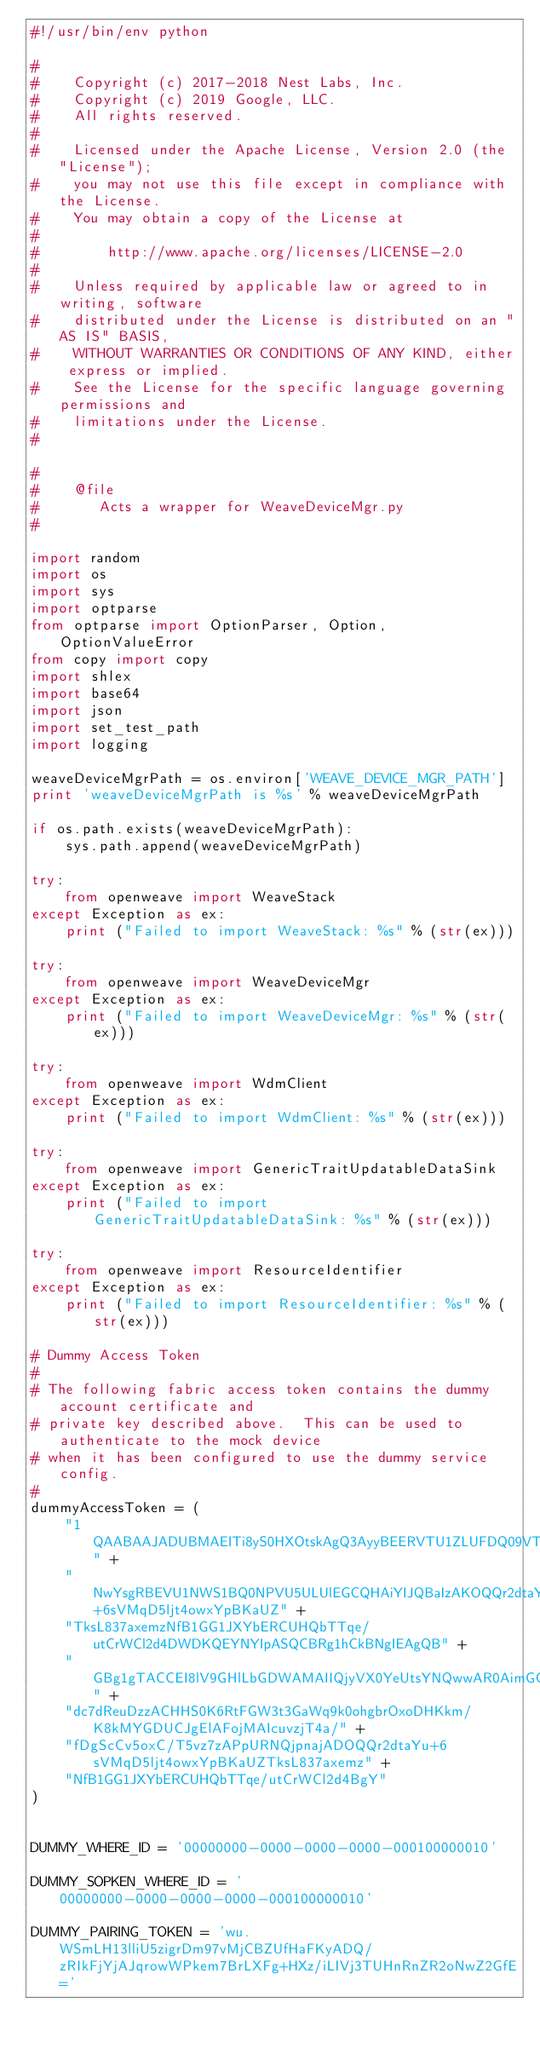Convert code to text. <code><loc_0><loc_0><loc_500><loc_500><_Python_>#!/usr/bin/env python

#
#    Copyright (c) 2017-2018 Nest Labs, Inc.
#    Copyright (c) 2019 Google, LLC.
#    All rights reserved.
#
#    Licensed under the Apache License, Version 2.0 (the "License");
#    you may not use this file except in compliance with the License.
#    You may obtain a copy of the License at
#
#        http://www.apache.org/licenses/LICENSE-2.0
#
#    Unless required by applicable law or agreed to in writing, software
#    distributed under the License is distributed on an "AS IS" BASIS,
#    WITHOUT WARRANTIES OR CONDITIONS OF ANY KIND, either express or implied.
#    See the License for the specific language governing permissions and
#    limitations under the License.
#

#
#    @file
#       Acts a wrapper for WeaveDeviceMgr.py
#

import random
import os
import sys
import optparse
from optparse import OptionParser, Option, OptionValueError
from copy import copy
import shlex
import base64
import json
import set_test_path
import logging

weaveDeviceMgrPath = os.environ['WEAVE_DEVICE_MGR_PATH']
print 'weaveDeviceMgrPath is %s' % weaveDeviceMgrPath

if os.path.exists(weaveDeviceMgrPath):
    sys.path.append(weaveDeviceMgrPath)

try:
    from openweave import WeaveStack
except Exception as ex:
    print ("Failed to import WeaveStack: %s" % (str(ex)))

try:
    from openweave import WeaveDeviceMgr
except Exception as ex:
    print ("Failed to import WeaveDeviceMgr: %s" % (str(ex)))

try:
    from openweave import WdmClient
except Exception as ex:
    print ("Failed to import WdmClient: %s" % (str(ex)))

try:
    from openweave import GenericTraitUpdatableDataSink
except Exception as ex:
    print ("Failed to import GenericTraitUpdatableDataSink: %s" % (str(ex)))

try:
    from openweave import ResourceIdentifier
except Exception as ex:
    print ("Failed to import ResourceIdentifier: %s" % (str(ex)))

# Dummy Access Token
#
# The following fabric access token contains the dummy account certificate and
# private key described above.  This can be used to authenticate to the mock device
# when it has been configured to use the dummy service config.
#
dummyAccessToken = (
    "1QAABAAJADUBMAEITi8yS0HXOtskAgQ3AyyBEERVTU1ZLUFDQ09VTlQtSUQYJgTLqPobJgVLNU9C" +
    "NwYsgRBEVU1NWS1BQ0NPVU5ULUlEGCQHAiYIJQBaIzAKOQQr2dtaYu+6sVMqD5ljt4owxYpBKaUZ" +
    "TksL837axemzNfB1GG1JXYbERCUHQbTTqe/utCrWCl2d4DWDKQEYNYIpASQCBRg1hCkBNgIEAgQB" +
    "GBg1gTACCEI8lV9GHlLbGDWAMAIIQjyVX0YeUtsYNQwwAR0AimGGYj0XstLP0m05PeQlaeCR6gVq" +
    "dc7dReuDzzACHHS0K6RtFGW3t3GaWq9k0ohgbrOxoDHKkm/K8kMYGDUCJgElAFojMAIcuvzjT4a/" +
    "fDgScCv5oxC/T5vz7zAPpURNQjpnajADOQQr2dtaYu+6sVMqD5ljt4owxYpBKaUZTksL837axemz" +
    "NfB1GG1JXYbERCUHQbTTqe/utCrWCl2d4BgY"
)


DUMMY_WHERE_ID = '00000000-0000-0000-0000-000100000010'

DUMMY_SOPKEN_WHERE_ID = '00000000-0000-0000-0000-000100000010'

DUMMY_PAIRING_TOKEN = 'wu.WSmLH13lliU5zigrDm97vMjCBZUfHaFKyADQ/zRIkFjYjAJqrowWPkem7BrLXFg+HXz/iLIVj3TUHnRnZR2oNwZ2GfE='
</code> 